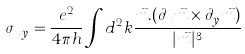Convert formula to latex. <formula><loc_0><loc_0><loc_500><loc_500>\sigma _ { x y } = \frac { e ^ { 2 } } { 4 \pi h } \int d ^ { 2 } k \frac { \vec { m } . ( \partial _ { x } \vec { m } \times \partial _ { y } \vec { m } ) } { | \vec { m } | ^ { 3 } }</formula> 